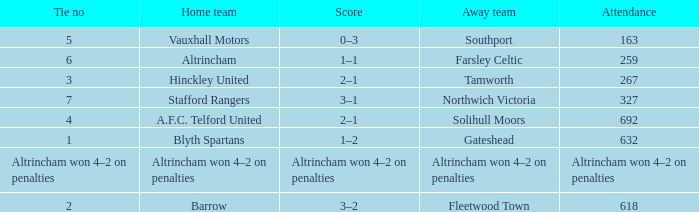Which away team that had a tie of 7? Northwich Victoria. 